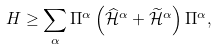Convert formula to latex. <formula><loc_0><loc_0><loc_500><loc_500>H \geq \sum _ { \alpha } \Pi ^ { \alpha } \left ( \widehat { \mathcal { H } } ^ { \alpha } + \widetilde { \mathcal { H } } ^ { \alpha } \right ) \Pi ^ { \alpha } ,</formula> 